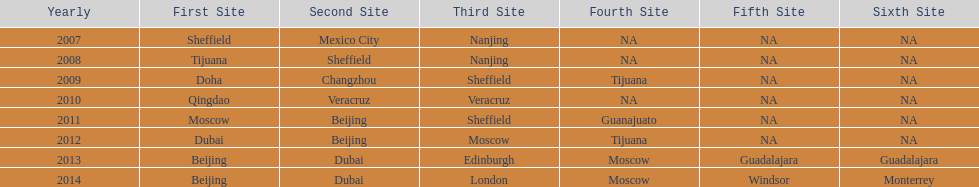Which two places had no countries present from 2007 to 2012? 5th Venue, 6th Venue. 